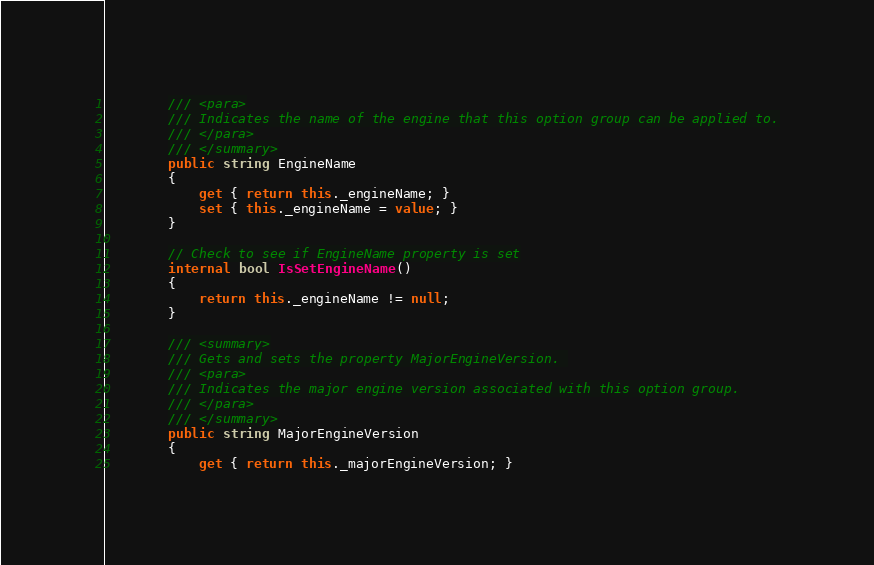Convert code to text. <code><loc_0><loc_0><loc_500><loc_500><_C#_>        /// <para>
        /// Indicates the name of the engine that this option group can be applied to.
        /// </para>
        /// </summary>
        public string EngineName
        {
            get { return this._engineName; }
            set { this._engineName = value; }
        }

        // Check to see if EngineName property is set
        internal bool IsSetEngineName()
        {
            return this._engineName != null;
        }

        /// <summary>
        /// Gets and sets the property MajorEngineVersion. 
        /// <para>
        /// Indicates the major engine version associated with this option group.
        /// </para>
        /// </summary>
        public string MajorEngineVersion
        {
            get { return this._majorEngineVersion; }</code> 